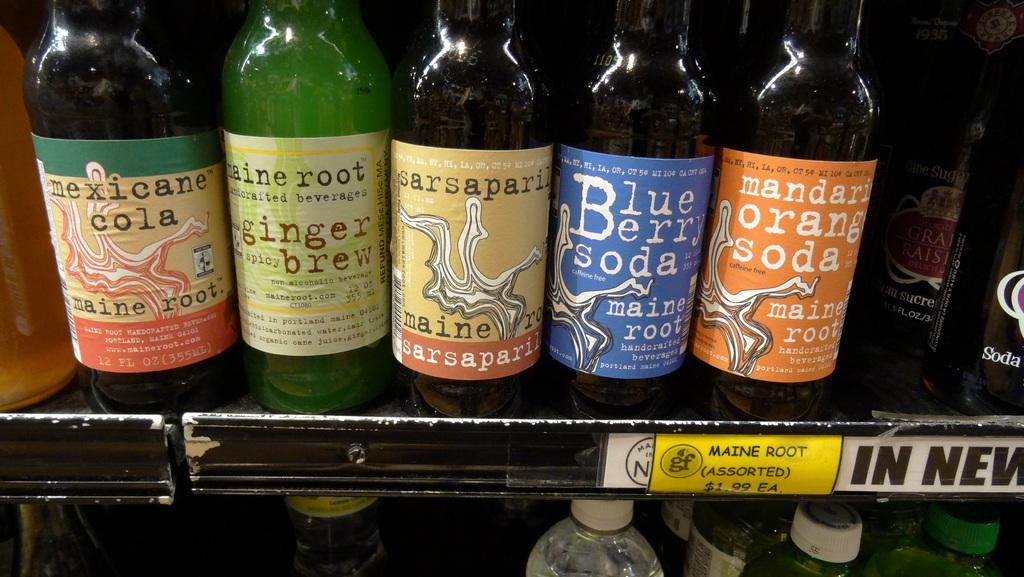<image>
Describe the image concisely. Five different types of soda of an uncommon brand are displayed on a shelf. 